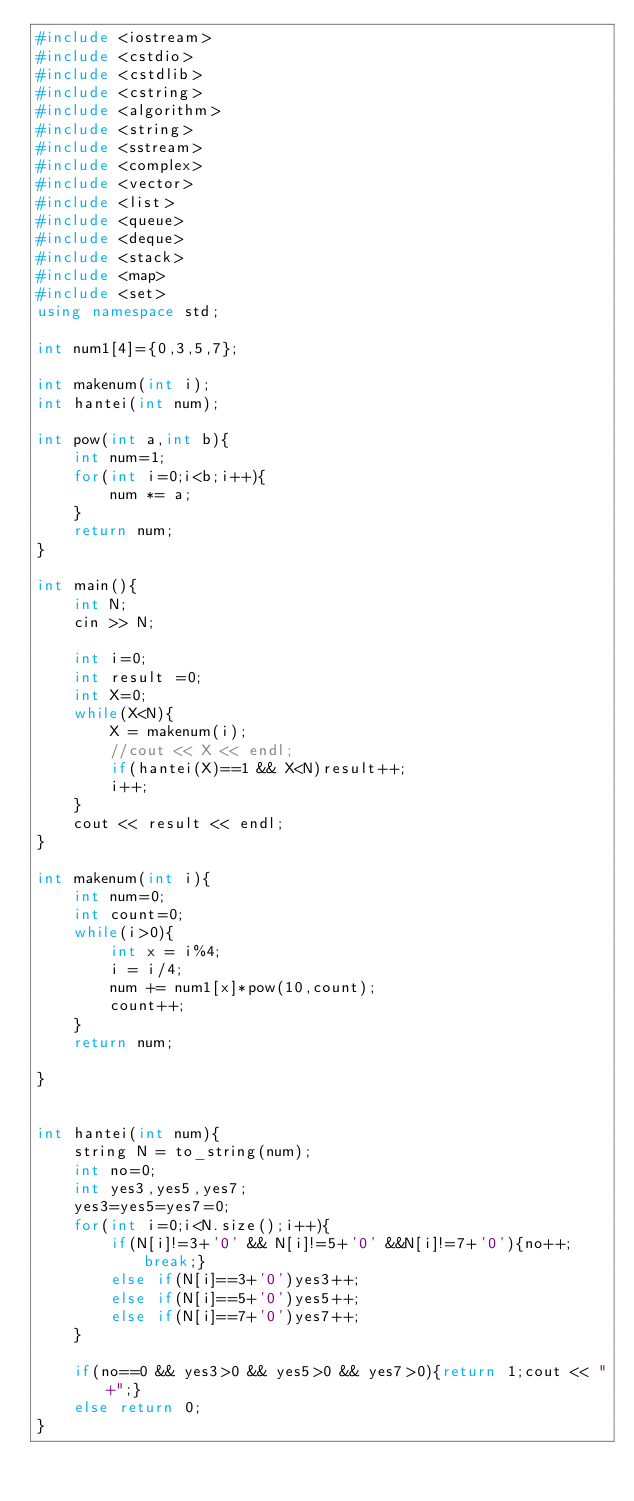Convert code to text. <code><loc_0><loc_0><loc_500><loc_500><_C++_>#include <iostream>
#include <cstdio>
#include <cstdlib>
#include <cstring>
#include <algorithm>
#include <string>
#include <sstream>
#include <complex>
#include <vector>
#include <list>
#include <queue>
#include <deque>
#include <stack>
#include <map>
#include <set>
using namespace std;

int num1[4]={0,3,5,7};

int makenum(int i);
int hantei(int num);

int pow(int a,int b){
    int num=1;
    for(int i=0;i<b;i++){
        num *= a;
    }
    return num;
}

int main(){
    int N;
    cin >> N;

    int i=0;
    int result =0;
    int X=0;
    while(X<N){
        X = makenum(i);
        //cout << X << endl;
        if(hantei(X)==1 && X<N)result++;
        i++;
    }
    cout << result << endl; 
}

int makenum(int i){
    int num=0;
    int count=0;
    while(i>0){
        int x = i%4;
        i = i/4;
        num += num1[x]*pow(10,count);
        count++;
    }
    return num;

}


int hantei(int num){
    string N = to_string(num);
    int no=0;
    int yes3,yes5,yes7;
    yes3=yes5=yes7=0;
    for(int i=0;i<N.size();i++){
        if(N[i]!=3+'0' && N[i]!=5+'0' &&N[i]!=7+'0'){no++;break;}
        else if(N[i]==3+'0')yes3++;
        else if(N[i]==5+'0')yes5++;
        else if(N[i]==7+'0')yes7++;
    }

    if(no==0 && yes3>0 && yes5>0 && yes7>0){return 1;cout << "+";}
    else return 0;
}</code> 